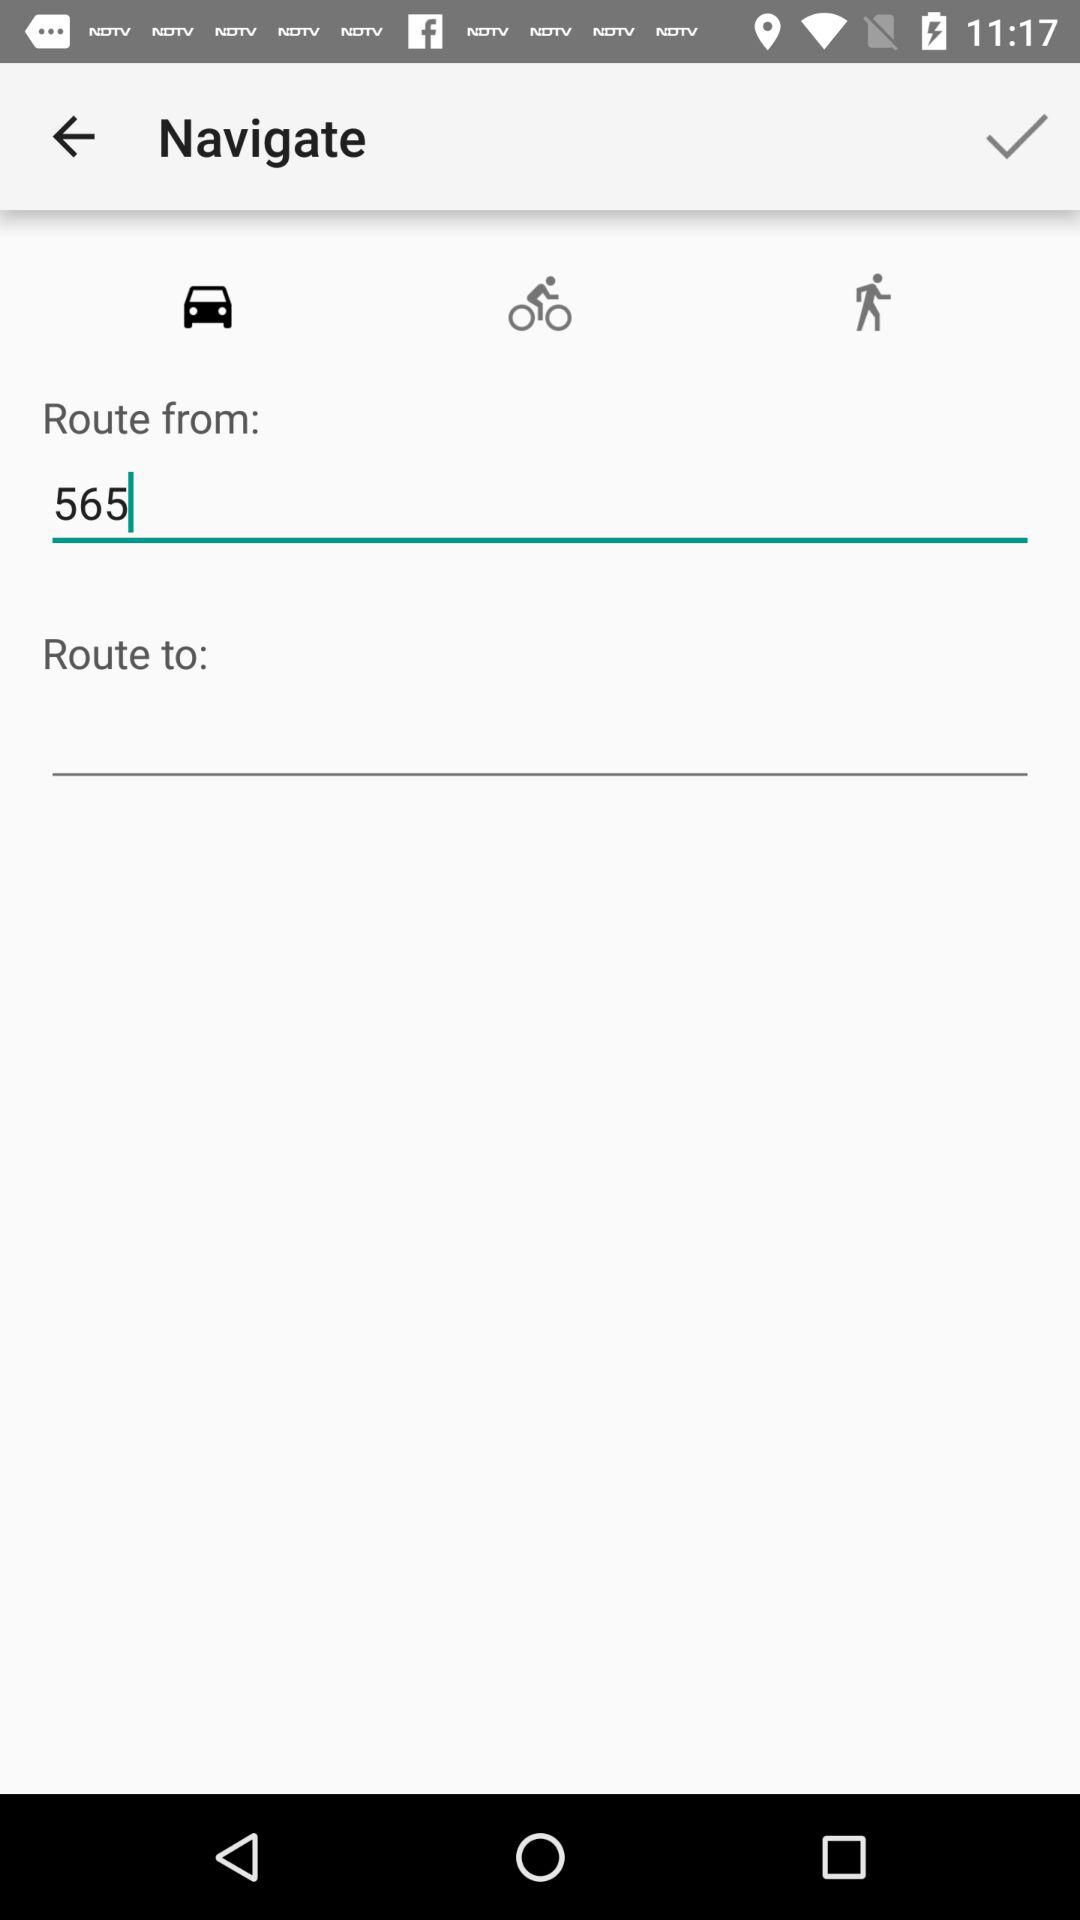How many types of navigation are available?
Answer the question using a single word or phrase. 3 